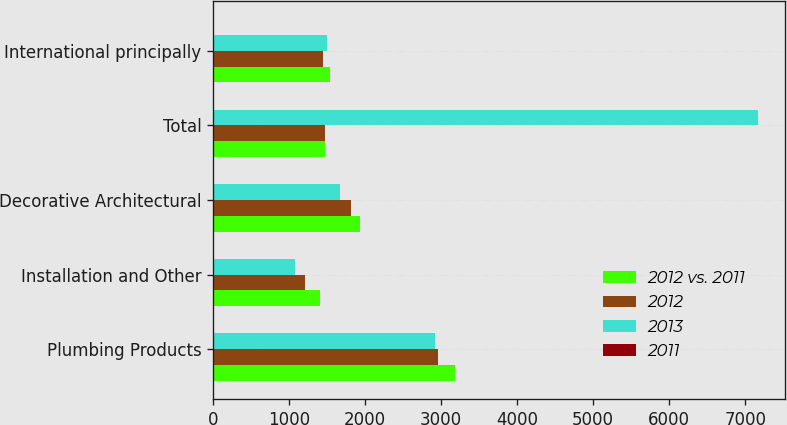Convert chart to OTSL. <chart><loc_0><loc_0><loc_500><loc_500><stacked_bar_chart><ecel><fcel>Plumbing Products<fcel>Installation and Other<fcel>Decorative Architectural<fcel>Total<fcel>International principally<nl><fcel>2012 vs. 2011<fcel>3183<fcel>1412<fcel>1927<fcel>1475<fcel>1539<nl><fcel>2012<fcel>2955<fcel>1209<fcel>1818<fcel>1475<fcel>1449<nl><fcel>2013<fcel>2913<fcel>1077<fcel>1670<fcel>7170<fcel>1501<nl><fcel>2011<fcel>8<fcel>17<fcel>6<fcel>9<fcel>6<nl></chart> 